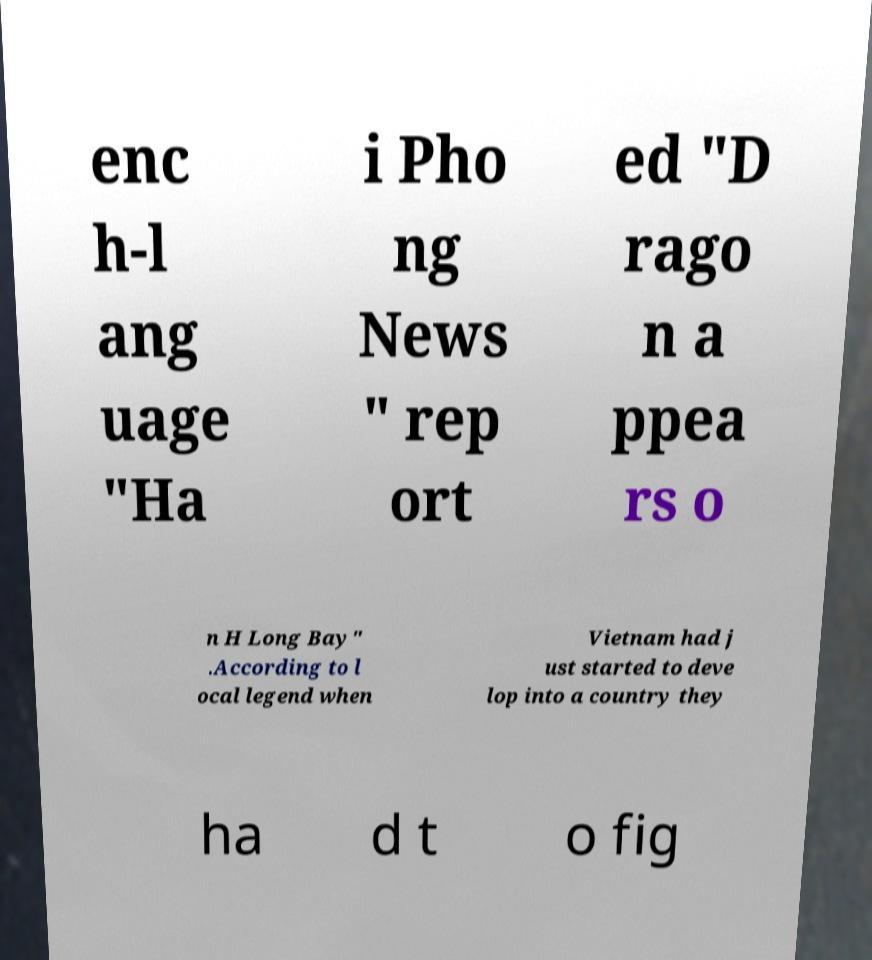Please identify and transcribe the text found in this image. enc h-l ang uage "Ha i Pho ng News " rep ort ed "D rago n a ppea rs o n H Long Bay" .According to l ocal legend when Vietnam had j ust started to deve lop into a country they ha d t o fig 